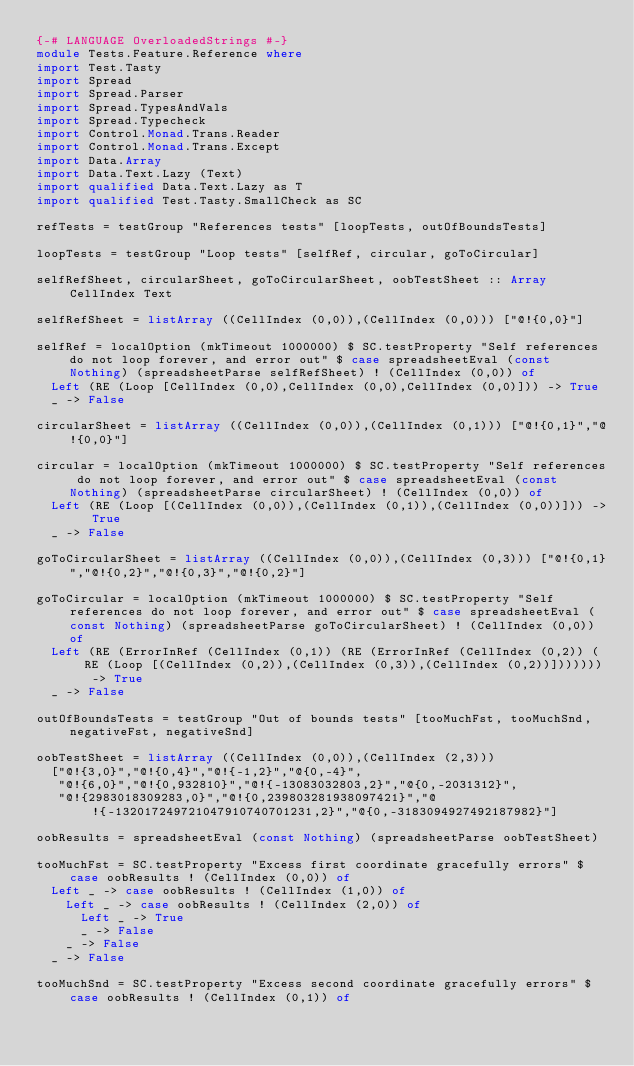<code> <loc_0><loc_0><loc_500><loc_500><_Haskell_>{-# LANGUAGE OverloadedStrings #-}
module Tests.Feature.Reference where
import Test.Tasty
import Spread
import Spread.Parser
import Spread.TypesAndVals
import Spread.Typecheck
import Control.Monad.Trans.Reader
import Control.Monad.Trans.Except
import Data.Array
import Data.Text.Lazy (Text)
import qualified Data.Text.Lazy as T
import qualified Test.Tasty.SmallCheck as SC

refTests = testGroup "References tests" [loopTests, outOfBoundsTests]

loopTests = testGroup "Loop tests" [selfRef, circular, goToCircular]

selfRefSheet, circularSheet, goToCircularSheet, oobTestSheet :: Array CellIndex Text

selfRefSheet = listArray ((CellIndex (0,0)),(CellIndex (0,0))) ["@!{0,0}"]

selfRef = localOption (mkTimeout 1000000) $ SC.testProperty "Self references do not loop forever, and error out" $ case spreadsheetEval (const Nothing) (spreadsheetParse selfRefSheet) ! (CellIndex (0,0)) of
  Left (RE (Loop [CellIndex (0,0),CellIndex (0,0),CellIndex (0,0)])) -> True
  _ -> False

circularSheet = listArray ((CellIndex (0,0)),(CellIndex (0,1))) ["@!{0,1}","@!{0,0}"]

circular = localOption (mkTimeout 1000000) $ SC.testProperty "Self references do not loop forever, and error out" $ case spreadsheetEval (const Nothing) (spreadsheetParse circularSheet) ! (CellIndex (0,0)) of
  Left (RE (Loop [(CellIndex (0,0)),(CellIndex (0,1)),(CellIndex (0,0))])) -> True
  _ -> False

goToCircularSheet = listArray ((CellIndex (0,0)),(CellIndex (0,3))) ["@!{0,1}","@!{0,2}","@!{0,3}","@!{0,2}"]

goToCircular = localOption (mkTimeout 1000000) $ SC.testProperty "Self references do not loop forever, and error out" $ case spreadsheetEval (const Nothing) (spreadsheetParse goToCircularSheet) ! (CellIndex (0,0)) of
  Left (RE (ErrorInRef (CellIndex (0,1)) (RE (ErrorInRef (CellIndex (0,2)) (RE (Loop [(CellIndex (0,2)),(CellIndex (0,3)),(CellIndex (0,2))])))))) -> True
  _ -> False

outOfBoundsTests = testGroup "Out of bounds tests" [tooMuchFst, tooMuchSnd, negativeFst, negativeSnd]

oobTestSheet = listArray ((CellIndex (0,0)),(CellIndex (2,3)))
  ["@!{3,0}","@!{0,4}","@!{-1,2}","@{0,-4}",
   "@!{6,0}","@!{0,932810}","@!{-13083032803,2}","@{0,-2031312}",
   "@!{2983018309283,0}","@!{0,239803281938097421}","@!{-132017249721047910740701231,2}","@{0,-3183094927492187982}"]

oobResults = spreadsheetEval (const Nothing) (spreadsheetParse oobTestSheet) 

tooMuchFst = SC.testProperty "Excess first coordinate gracefully errors" $ case oobResults ! (CellIndex (0,0)) of 
  Left _ -> case oobResults ! (CellIndex (1,0)) of
    Left _ -> case oobResults ! (CellIndex (2,0)) of
      Left _ -> True
      _ -> False
    _ -> False
  _ -> False

tooMuchSnd = SC.testProperty "Excess second coordinate gracefully errors" $ case oobResults ! (CellIndex (0,1)) of </code> 